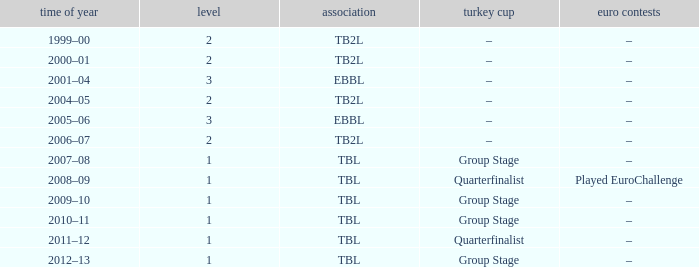Tier of 2, and a Season of 2004–05 is what European competitions? –. 